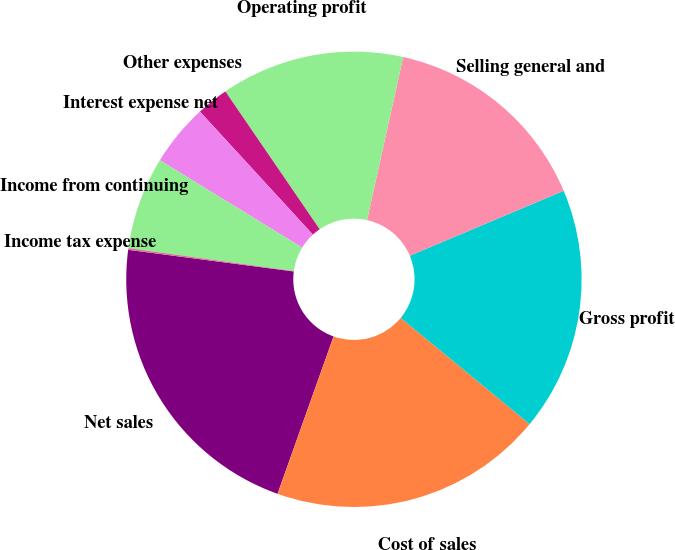Convert chart. <chart><loc_0><loc_0><loc_500><loc_500><pie_chart><fcel>Net sales<fcel>Cost of sales<fcel>Gross profit<fcel>Selling general and<fcel>Operating profit<fcel>Other expenses<fcel>Interest expense net<fcel>Income from continuing<fcel>Income tax expense<nl><fcel>21.62%<fcel>19.47%<fcel>17.32%<fcel>15.17%<fcel>13.02%<fcel>2.27%<fcel>4.42%<fcel>6.57%<fcel>0.12%<nl></chart> 